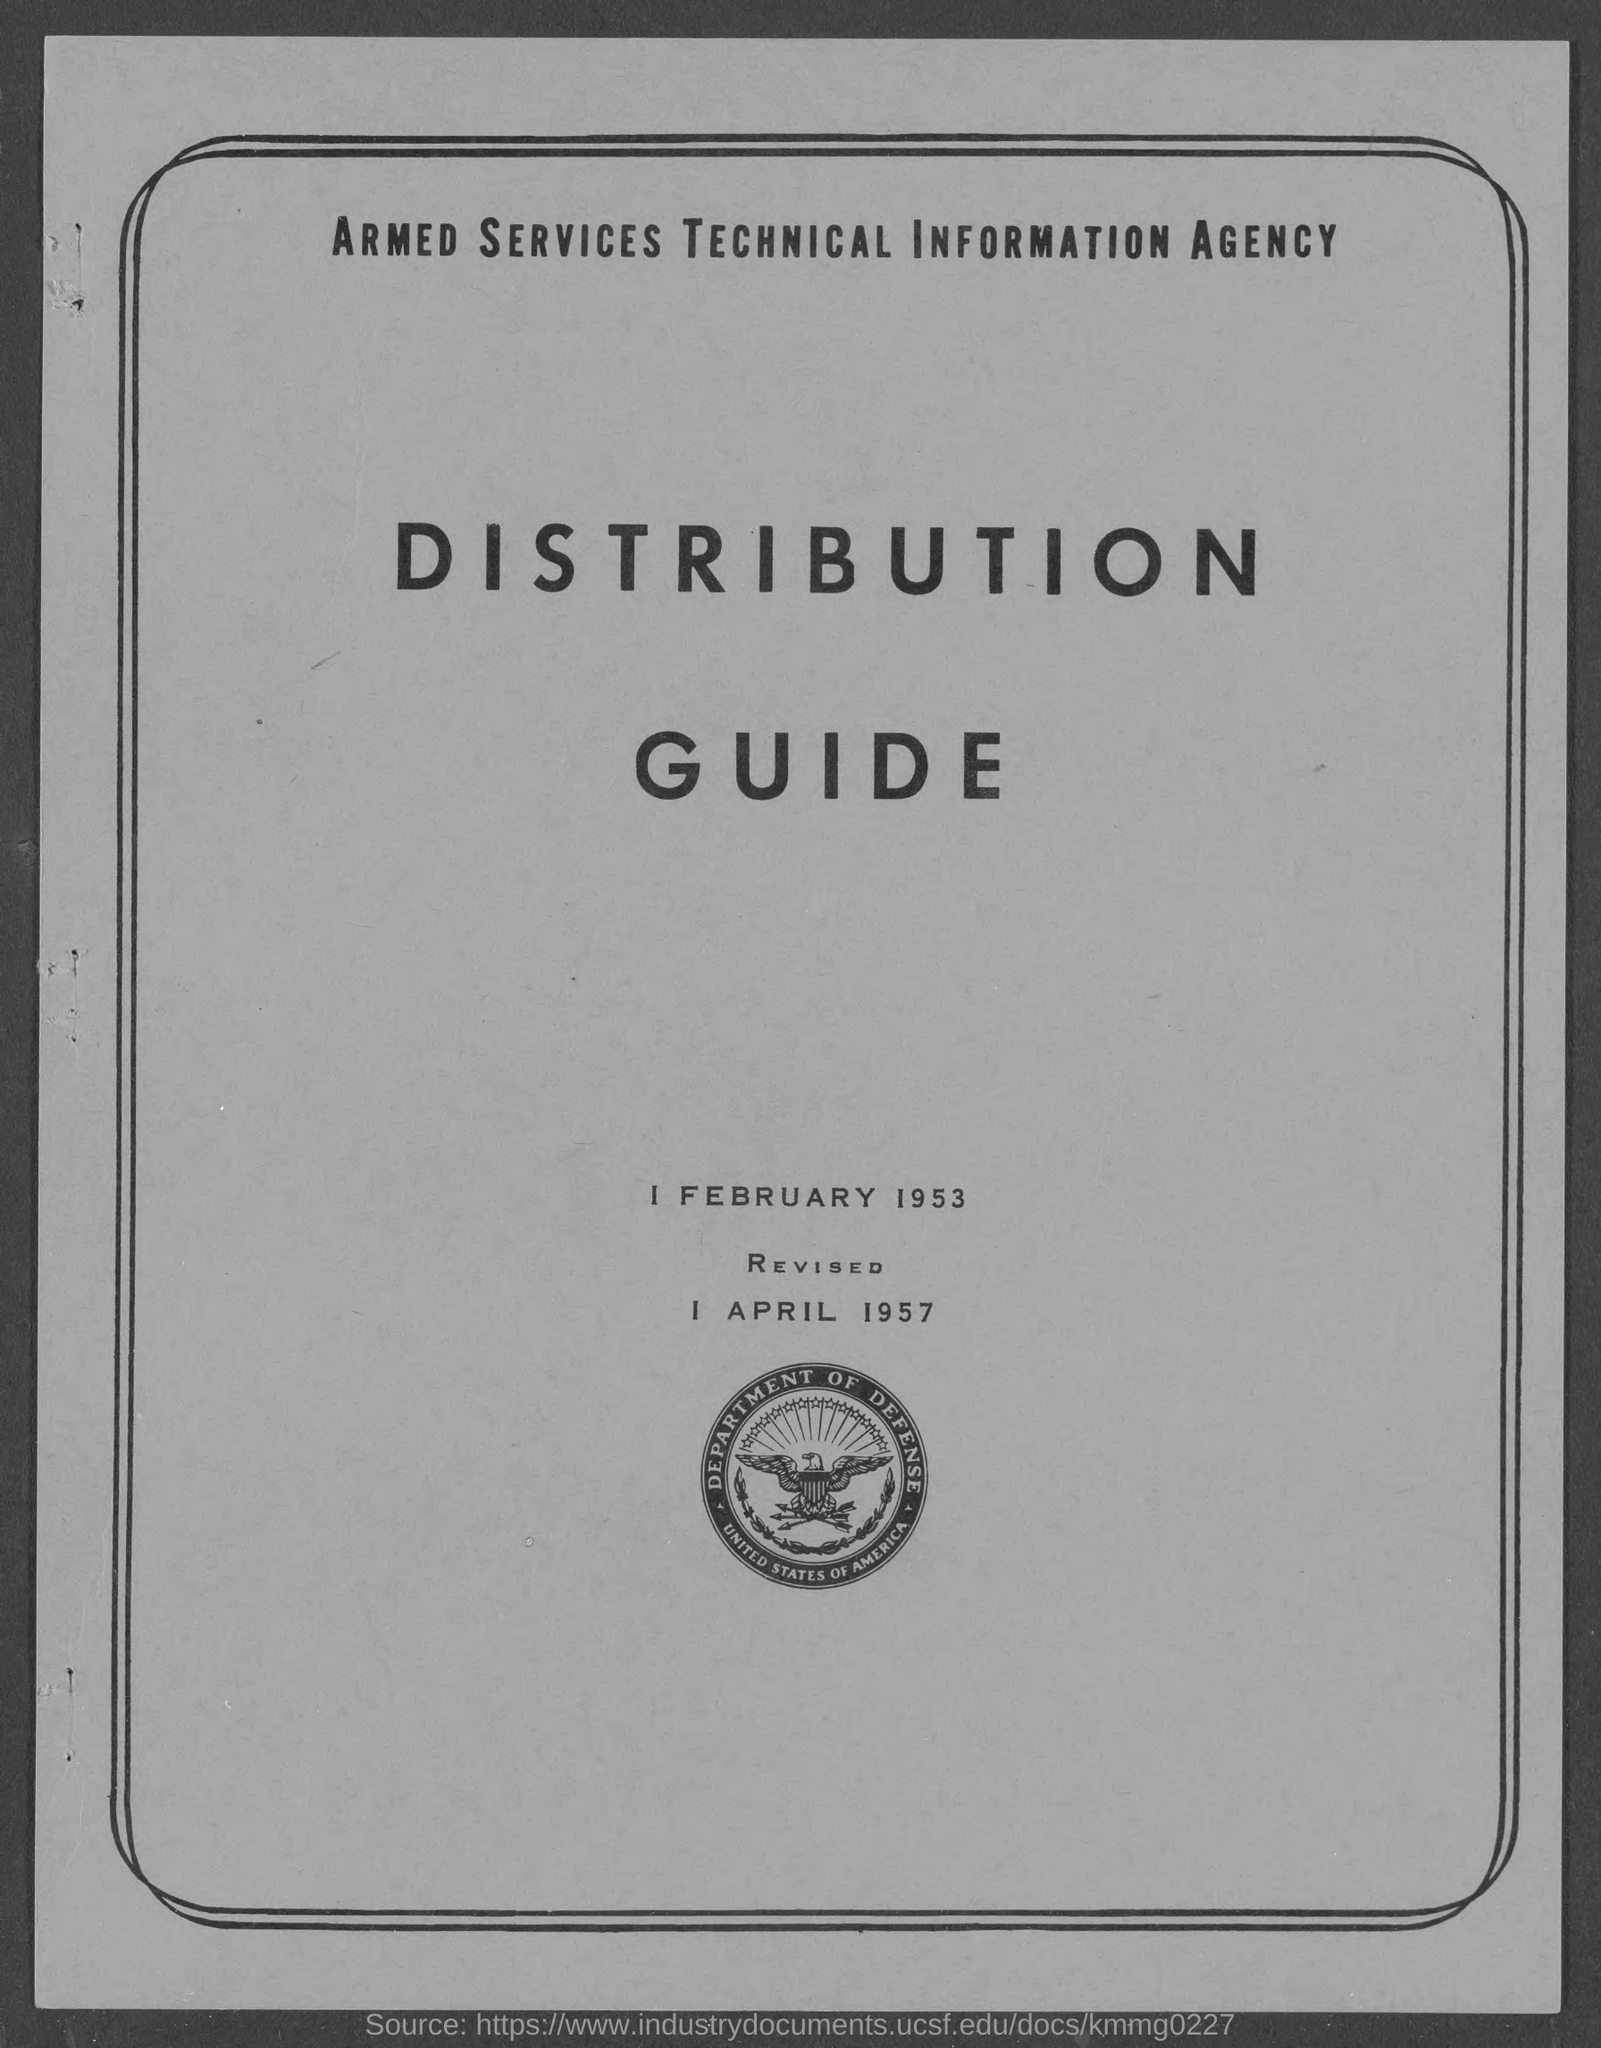What is the name of the agency?
Ensure brevity in your answer.  Armed services technical information agency. The name of which department is given on the emblem?
Ensure brevity in your answer.  Department of defense. The name of which country is given on the emblem?
Your answer should be compact. United States of America. On which date has the document been revised?
Offer a very short reply. 1 April 1957. 